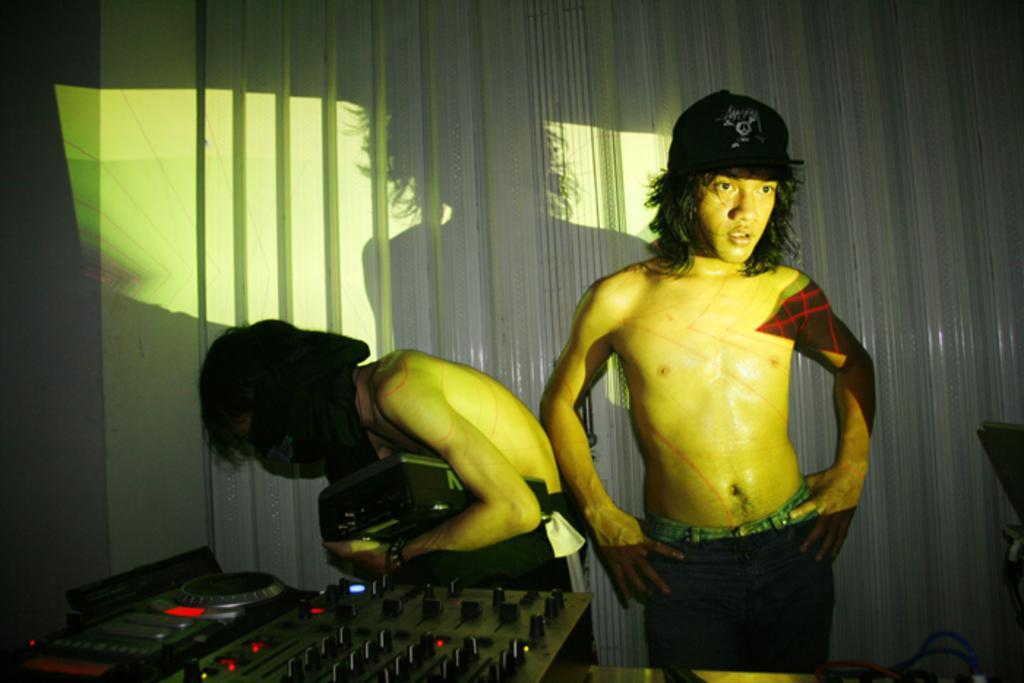In one or two sentences, can you explain what this image depicts? Here two people are standing, here there is a musical instrument. 